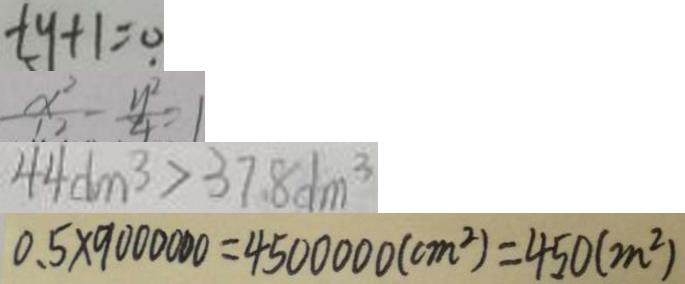Convert formula to latex. <formula><loc_0><loc_0><loc_500><loc_500>t y + 1 = 0 
 \frac { x ^ { 2 } } { 1 2 } - \frac { y ^ { 2 } } { 4 } = 1 
 4 4 d m ^ { 3 } > 3 7 . 8 d m ^ { 3 } 
 0 . 5 \times 9 0 0 0 0 0 0 = 4 5 0 0 0 0 0 ( c m ^ { 2 } ) = 4 5 0 ( m ^ { 2 } )</formula> 